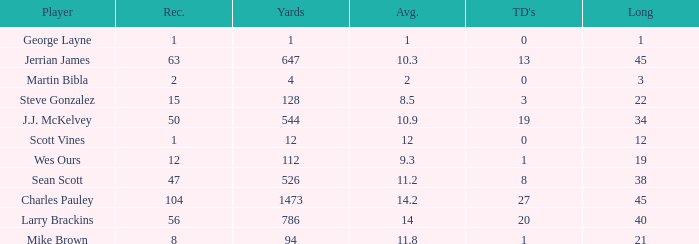How many receptions for players with over 647 yards and an under 14 yard average? None. 